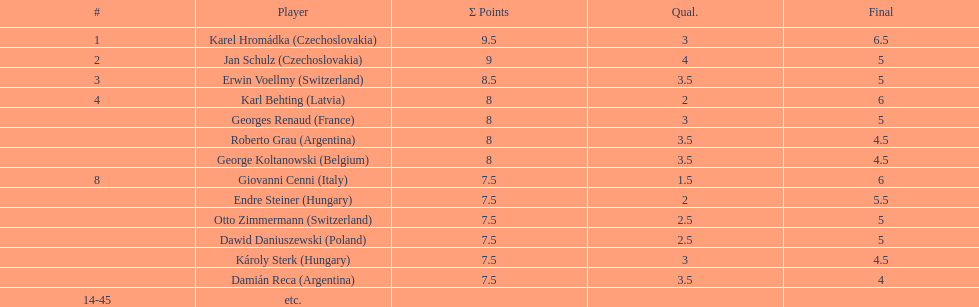Karl behting and giovanni cenni each had final scores of what? 6. 